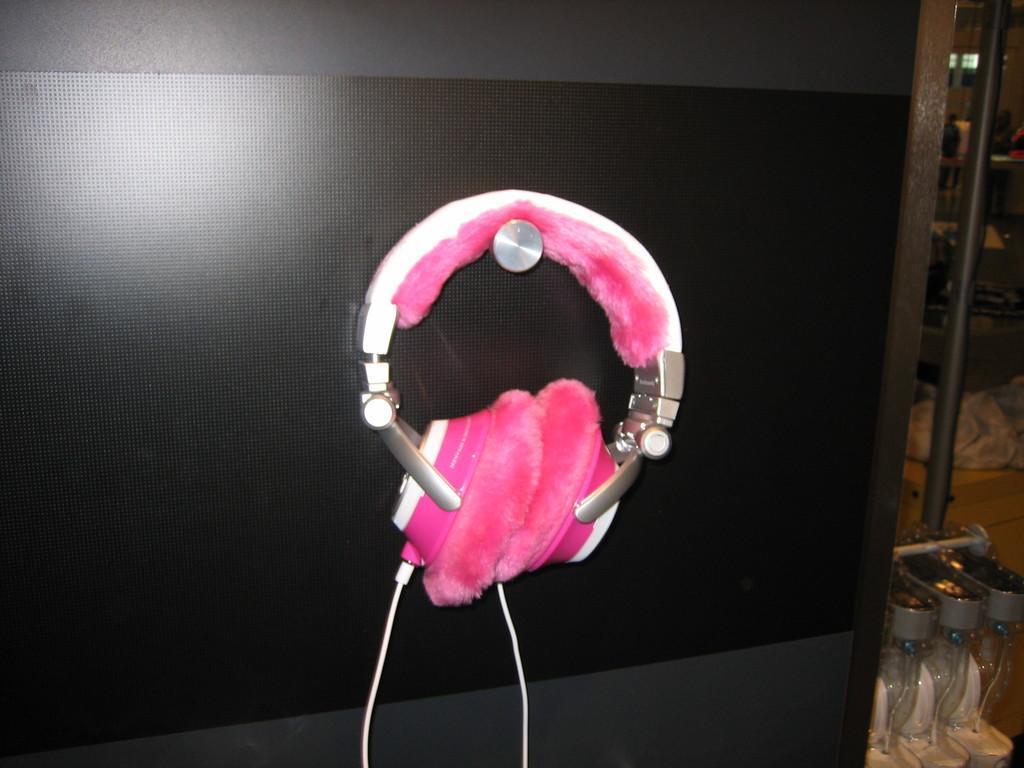Can you describe this image briefly? In this picture we can see headphones, cable, wall, pole and in the background we can see some objects. 